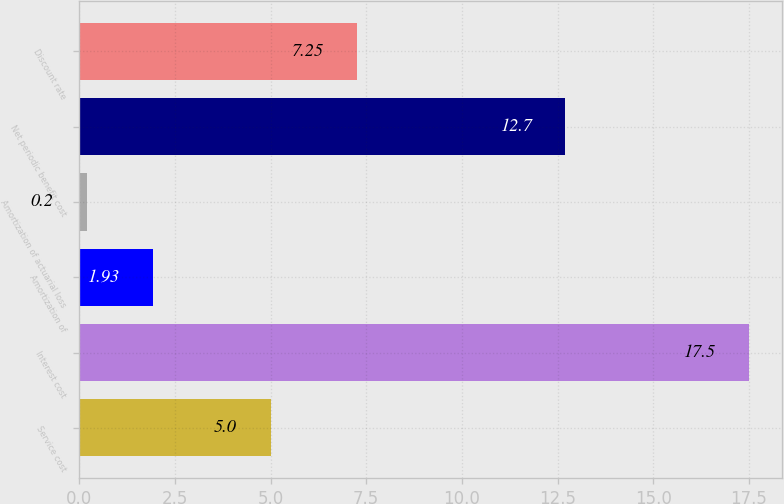Convert chart. <chart><loc_0><loc_0><loc_500><loc_500><bar_chart><fcel>Service cost<fcel>Interest cost<fcel>Amortization of<fcel>Amortization of actuarial loss<fcel>Net periodic benefit cost<fcel>Discount rate<nl><fcel>5<fcel>17.5<fcel>1.93<fcel>0.2<fcel>12.7<fcel>7.25<nl></chart> 